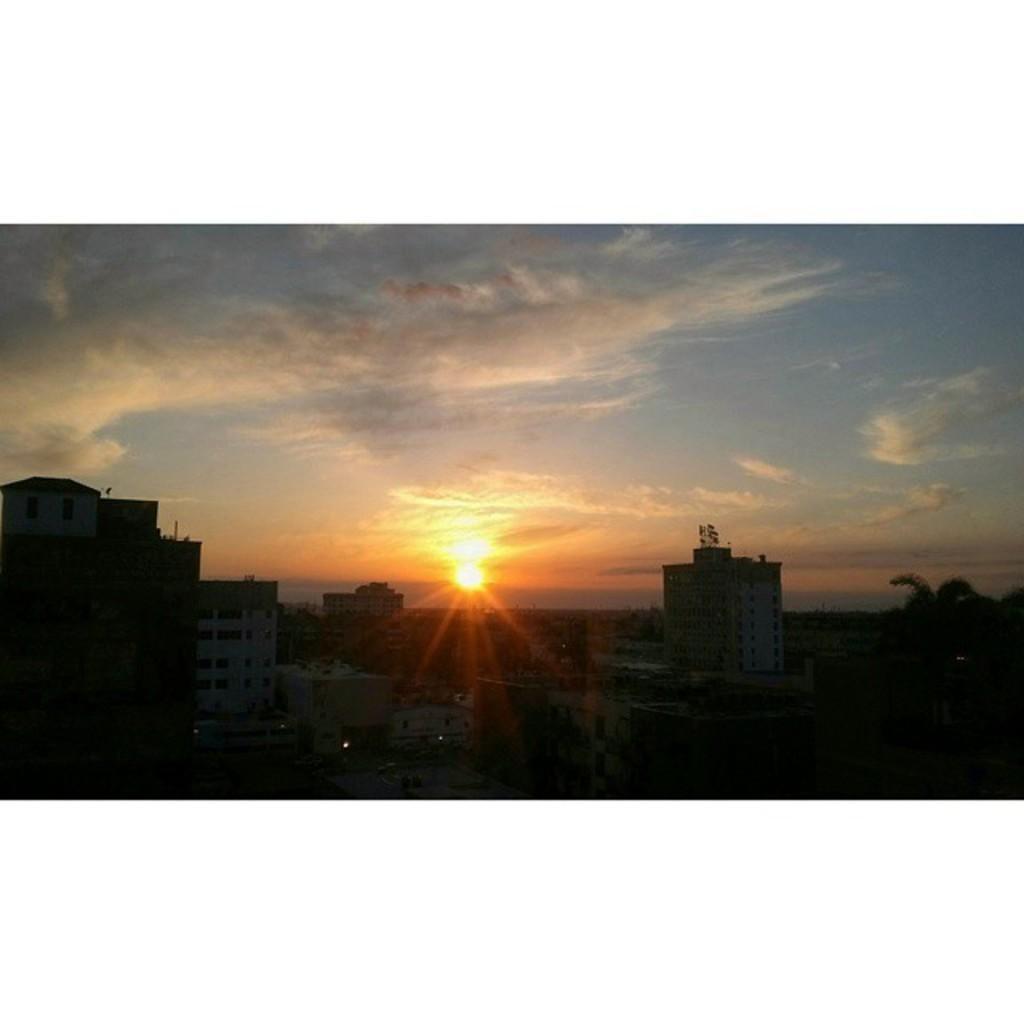Could you give a brief overview of what you see in this image? This is an outside view. At the bottom there are many buildings and trees in the dark. At the top of the image, I can see in the sky along with the sun and clouds. 